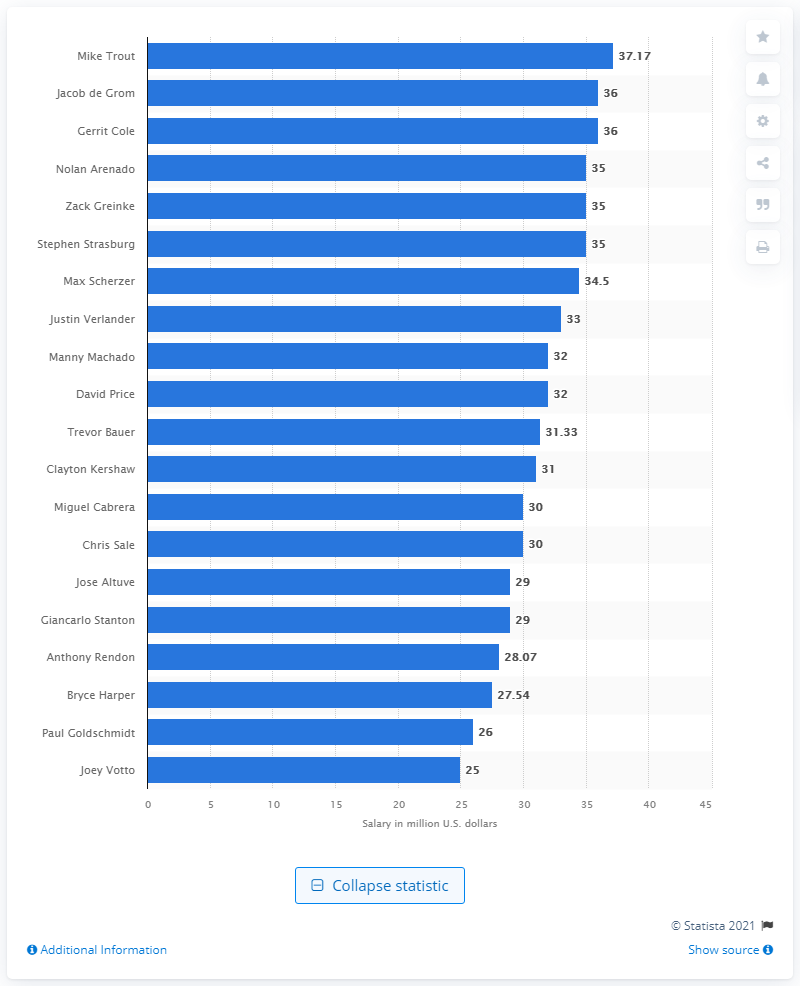Identify some key points in this picture. In the 2021 season, Mike Trout's annual salary was 37.17 million dollars. In 2021, Mike Trout was the highest earner in the MLB. 